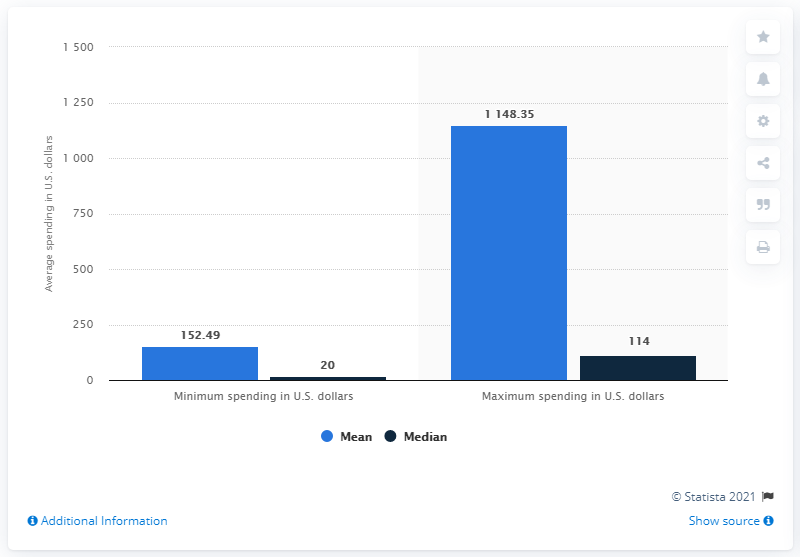List a handful of essential elements in this visual. In 2020, the median maximum amount spent per mobile wallet transaction was 114. 